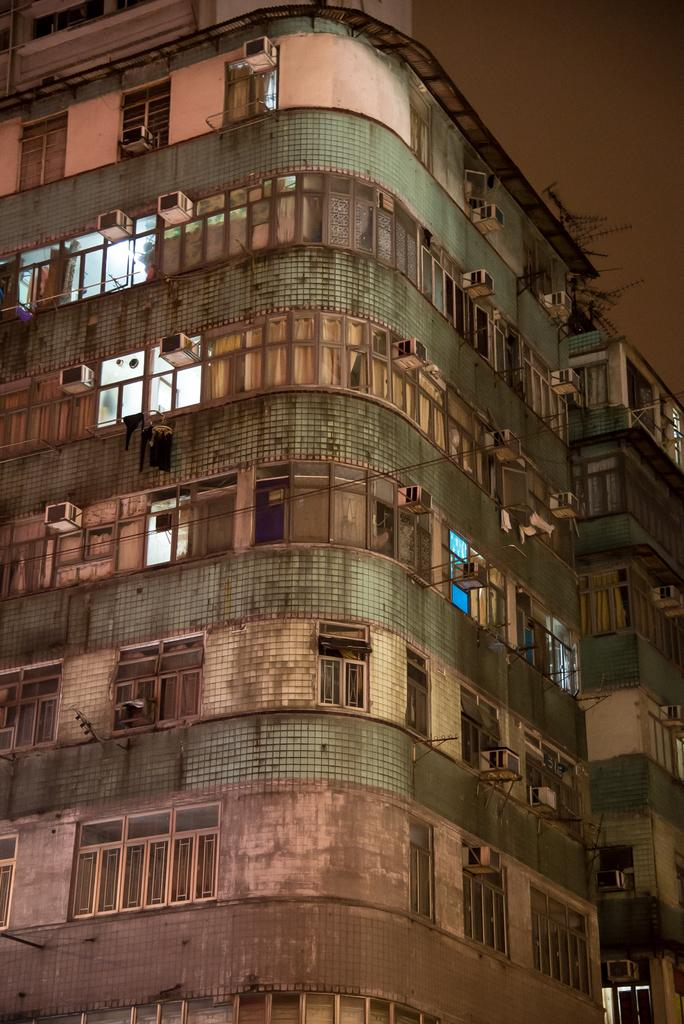What is the main subject in the center of the image? There is a building in the center of the image. What can be seen in the background of the image? The sky is visible in the background of the image. How many letters are visible on the building's facade in the image? There is no information provided about letters on the building's facade, so we cannot determine the number of letters visible. 